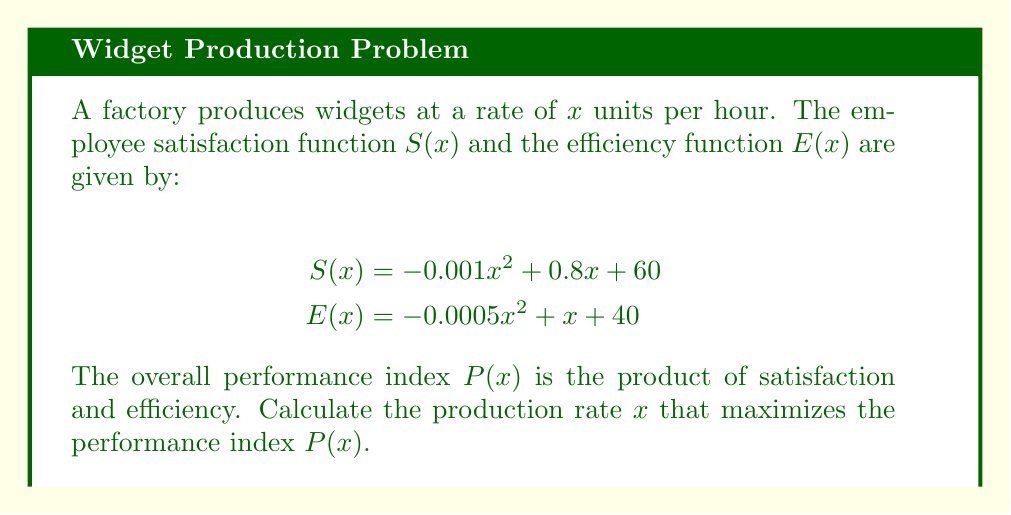What is the answer to this math problem? 1. The performance index $P(x)$ is the product of $S(x)$ and $E(x)$:
   $$P(x) = S(x) \cdot E(x)$$

2. Expand $P(x)$:
   $$P(x) = (-0.001x^2 + 0.8x + 60)(-0.0005x^2 + x + 40)$$

3. Multiply the terms:
   $$P(x) = 0.0000005x^4 - 0.0009x^3 - 0.34x^2 + 92x + 2400$$

4. To find the maximum, we need to find where $\frac{dP}{dx} = 0$:
   $$\frac{dP}{dx} = 0.000002x^3 - 0.0027x^2 - 0.68x + 92$$

5. Set this equal to zero and solve for $x$:
   $$0.000002x^3 - 0.0027x^2 - 0.68x + 92 = 0$$

6. This cubic equation is difficult to solve analytically. Using numerical methods or a graphing calculator, we find that the solution that maximizes $P(x)$ is approximately:
   $$x \approx 400$$

7. To verify this is a maximum, we can check that the second derivative is negative at this point:
   $$\frac{d^2P}{dx^2} = 0.000006x^2 - 0.0054x - 0.68$$
   At $x = 400$: $\frac{d^2P}{dx^2} \approx -2.44 < 0$, confirming a maximum.
Answer: 400 units per hour 